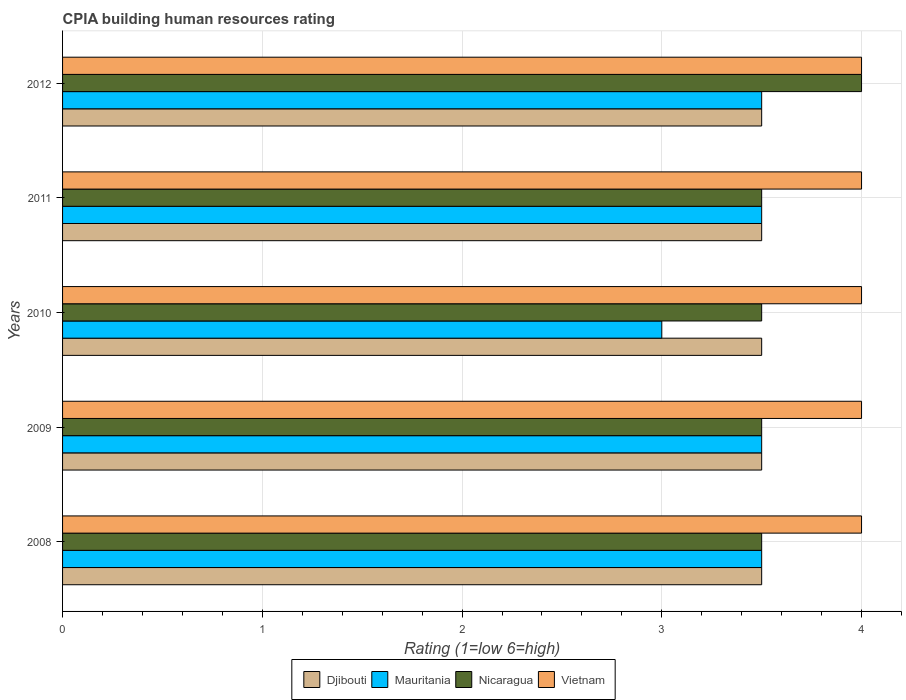How many different coloured bars are there?
Provide a short and direct response. 4. Are the number of bars per tick equal to the number of legend labels?
Ensure brevity in your answer.  Yes. How many bars are there on the 4th tick from the bottom?
Offer a very short reply. 4. Across all years, what is the maximum CPIA rating in Vietnam?
Provide a succinct answer. 4. Across all years, what is the minimum CPIA rating in Djibouti?
Offer a terse response. 3.5. In which year was the CPIA rating in Vietnam maximum?
Make the answer very short. 2008. What is the total CPIA rating in Mauritania in the graph?
Your response must be concise. 17. What is the difference between the CPIA rating in Djibouti in 2011 and the CPIA rating in Mauritania in 2008?
Offer a very short reply. 0. In how many years, is the CPIA rating in Vietnam greater than 2.6 ?
Keep it short and to the point. 5. Is the CPIA rating in Vietnam in 2008 less than that in 2011?
Your answer should be compact. No. Is the difference between the CPIA rating in Mauritania in 2009 and 2010 greater than the difference between the CPIA rating in Djibouti in 2009 and 2010?
Give a very brief answer. Yes. Is it the case that in every year, the sum of the CPIA rating in Nicaragua and CPIA rating in Vietnam is greater than the sum of CPIA rating in Mauritania and CPIA rating in Djibouti?
Provide a short and direct response. Yes. What does the 2nd bar from the top in 2009 represents?
Provide a succinct answer. Nicaragua. What does the 3rd bar from the bottom in 2012 represents?
Provide a short and direct response. Nicaragua. Is it the case that in every year, the sum of the CPIA rating in Nicaragua and CPIA rating in Djibouti is greater than the CPIA rating in Mauritania?
Provide a short and direct response. Yes. How many years are there in the graph?
Provide a short and direct response. 5. What is the difference between two consecutive major ticks on the X-axis?
Your answer should be very brief. 1. Where does the legend appear in the graph?
Ensure brevity in your answer.  Bottom center. What is the title of the graph?
Provide a succinct answer. CPIA building human resources rating. What is the label or title of the Y-axis?
Your response must be concise. Years. What is the Rating (1=low 6=high) in Djibouti in 2008?
Your answer should be very brief. 3.5. What is the Rating (1=low 6=high) of Vietnam in 2008?
Provide a succinct answer. 4. What is the Rating (1=low 6=high) of Djibouti in 2009?
Give a very brief answer. 3.5. What is the Rating (1=low 6=high) of Mauritania in 2009?
Provide a succinct answer. 3.5. What is the Rating (1=low 6=high) of Djibouti in 2011?
Ensure brevity in your answer.  3.5. What is the Rating (1=low 6=high) in Djibouti in 2012?
Offer a very short reply. 3.5. What is the Rating (1=low 6=high) of Mauritania in 2012?
Your response must be concise. 3.5. What is the Rating (1=low 6=high) in Nicaragua in 2012?
Ensure brevity in your answer.  4. What is the Rating (1=low 6=high) of Vietnam in 2012?
Provide a succinct answer. 4. Across all years, what is the maximum Rating (1=low 6=high) in Djibouti?
Provide a succinct answer. 3.5. Across all years, what is the maximum Rating (1=low 6=high) in Nicaragua?
Your response must be concise. 4. Across all years, what is the maximum Rating (1=low 6=high) of Vietnam?
Your response must be concise. 4. Across all years, what is the minimum Rating (1=low 6=high) of Vietnam?
Your answer should be compact. 4. What is the total Rating (1=low 6=high) of Nicaragua in the graph?
Offer a terse response. 18. What is the difference between the Rating (1=low 6=high) of Vietnam in 2008 and that in 2009?
Ensure brevity in your answer.  0. What is the difference between the Rating (1=low 6=high) in Djibouti in 2008 and that in 2010?
Offer a very short reply. 0. What is the difference between the Rating (1=low 6=high) in Mauritania in 2008 and that in 2010?
Give a very brief answer. 0.5. What is the difference between the Rating (1=low 6=high) of Nicaragua in 2008 and that in 2010?
Keep it short and to the point. 0. What is the difference between the Rating (1=low 6=high) in Djibouti in 2008 and that in 2011?
Offer a terse response. 0. What is the difference between the Rating (1=low 6=high) of Vietnam in 2008 and that in 2011?
Your response must be concise. 0. What is the difference between the Rating (1=low 6=high) of Mauritania in 2008 and that in 2012?
Keep it short and to the point. 0. What is the difference between the Rating (1=low 6=high) in Vietnam in 2008 and that in 2012?
Offer a very short reply. 0. What is the difference between the Rating (1=low 6=high) of Djibouti in 2009 and that in 2010?
Your answer should be very brief. 0. What is the difference between the Rating (1=low 6=high) of Nicaragua in 2009 and that in 2010?
Provide a succinct answer. 0. What is the difference between the Rating (1=low 6=high) in Vietnam in 2009 and that in 2010?
Keep it short and to the point. 0. What is the difference between the Rating (1=low 6=high) in Nicaragua in 2009 and that in 2011?
Your answer should be compact. 0. What is the difference between the Rating (1=low 6=high) in Djibouti in 2010 and that in 2011?
Ensure brevity in your answer.  0. What is the difference between the Rating (1=low 6=high) in Vietnam in 2010 and that in 2011?
Give a very brief answer. 0. What is the difference between the Rating (1=low 6=high) of Djibouti in 2010 and that in 2012?
Provide a succinct answer. 0. What is the difference between the Rating (1=low 6=high) in Nicaragua in 2010 and that in 2012?
Offer a terse response. -0.5. What is the difference between the Rating (1=low 6=high) in Djibouti in 2011 and that in 2012?
Ensure brevity in your answer.  0. What is the difference between the Rating (1=low 6=high) of Mauritania in 2011 and that in 2012?
Your response must be concise. 0. What is the difference between the Rating (1=low 6=high) of Djibouti in 2008 and the Rating (1=low 6=high) of Mauritania in 2009?
Keep it short and to the point. 0. What is the difference between the Rating (1=low 6=high) of Mauritania in 2008 and the Rating (1=low 6=high) of Nicaragua in 2009?
Your response must be concise. 0. What is the difference between the Rating (1=low 6=high) in Nicaragua in 2008 and the Rating (1=low 6=high) in Vietnam in 2009?
Ensure brevity in your answer.  -0.5. What is the difference between the Rating (1=low 6=high) of Djibouti in 2008 and the Rating (1=low 6=high) of Nicaragua in 2010?
Offer a terse response. 0. What is the difference between the Rating (1=low 6=high) of Djibouti in 2008 and the Rating (1=low 6=high) of Vietnam in 2010?
Ensure brevity in your answer.  -0.5. What is the difference between the Rating (1=low 6=high) in Djibouti in 2008 and the Rating (1=low 6=high) in Vietnam in 2011?
Your response must be concise. -0.5. What is the difference between the Rating (1=low 6=high) of Mauritania in 2008 and the Rating (1=low 6=high) of Nicaragua in 2011?
Ensure brevity in your answer.  0. What is the difference between the Rating (1=low 6=high) of Mauritania in 2008 and the Rating (1=low 6=high) of Vietnam in 2011?
Your answer should be compact. -0.5. What is the difference between the Rating (1=low 6=high) of Nicaragua in 2008 and the Rating (1=low 6=high) of Vietnam in 2011?
Provide a succinct answer. -0.5. What is the difference between the Rating (1=low 6=high) in Djibouti in 2008 and the Rating (1=low 6=high) in Mauritania in 2012?
Offer a very short reply. 0. What is the difference between the Rating (1=low 6=high) of Djibouti in 2008 and the Rating (1=low 6=high) of Nicaragua in 2012?
Your answer should be compact. -0.5. What is the difference between the Rating (1=low 6=high) in Djibouti in 2008 and the Rating (1=low 6=high) in Vietnam in 2012?
Provide a succinct answer. -0.5. What is the difference between the Rating (1=low 6=high) of Mauritania in 2008 and the Rating (1=low 6=high) of Nicaragua in 2012?
Keep it short and to the point. -0.5. What is the difference between the Rating (1=low 6=high) in Nicaragua in 2008 and the Rating (1=low 6=high) in Vietnam in 2012?
Your response must be concise. -0.5. What is the difference between the Rating (1=low 6=high) in Djibouti in 2009 and the Rating (1=low 6=high) in Mauritania in 2010?
Provide a short and direct response. 0.5. What is the difference between the Rating (1=low 6=high) of Djibouti in 2009 and the Rating (1=low 6=high) of Nicaragua in 2010?
Your response must be concise. 0. What is the difference between the Rating (1=low 6=high) in Djibouti in 2009 and the Rating (1=low 6=high) in Vietnam in 2010?
Provide a short and direct response. -0.5. What is the difference between the Rating (1=low 6=high) of Mauritania in 2009 and the Rating (1=low 6=high) of Nicaragua in 2010?
Offer a very short reply. 0. What is the difference between the Rating (1=low 6=high) of Nicaragua in 2009 and the Rating (1=low 6=high) of Vietnam in 2010?
Give a very brief answer. -0.5. What is the difference between the Rating (1=low 6=high) in Djibouti in 2009 and the Rating (1=low 6=high) in Mauritania in 2011?
Your answer should be compact. 0. What is the difference between the Rating (1=low 6=high) of Djibouti in 2009 and the Rating (1=low 6=high) of Vietnam in 2011?
Your answer should be very brief. -0.5. What is the difference between the Rating (1=low 6=high) in Djibouti in 2009 and the Rating (1=low 6=high) in Vietnam in 2012?
Keep it short and to the point. -0.5. What is the difference between the Rating (1=low 6=high) of Nicaragua in 2009 and the Rating (1=low 6=high) of Vietnam in 2012?
Your answer should be very brief. -0.5. What is the difference between the Rating (1=low 6=high) in Djibouti in 2010 and the Rating (1=low 6=high) in Mauritania in 2011?
Provide a succinct answer. 0. What is the difference between the Rating (1=low 6=high) of Djibouti in 2010 and the Rating (1=low 6=high) of Vietnam in 2011?
Ensure brevity in your answer.  -0.5. What is the difference between the Rating (1=low 6=high) in Mauritania in 2010 and the Rating (1=low 6=high) in Nicaragua in 2011?
Provide a succinct answer. -0.5. What is the difference between the Rating (1=low 6=high) of Mauritania in 2010 and the Rating (1=low 6=high) of Vietnam in 2011?
Keep it short and to the point. -1. What is the difference between the Rating (1=low 6=high) of Mauritania in 2010 and the Rating (1=low 6=high) of Nicaragua in 2012?
Make the answer very short. -1. What is the difference between the Rating (1=low 6=high) of Mauritania in 2010 and the Rating (1=low 6=high) of Vietnam in 2012?
Offer a very short reply. -1. What is the difference between the Rating (1=low 6=high) in Djibouti in 2011 and the Rating (1=low 6=high) in Vietnam in 2012?
Provide a succinct answer. -0.5. What is the average Rating (1=low 6=high) in Nicaragua per year?
Offer a terse response. 3.6. What is the average Rating (1=low 6=high) of Vietnam per year?
Your answer should be very brief. 4. In the year 2008, what is the difference between the Rating (1=low 6=high) in Djibouti and Rating (1=low 6=high) in Vietnam?
Offer a very short reply. -0.5. In the year 2009, what is the difference between the Rating (1=low 6=high) in Djibouti and Rating (1=low 6=high) in Vietnam?
Make the answer very short. -0.5. In the year 2009, what is the difference between the Rating (1=low 6=high) in Mauritania and Rating (1=low 6=high) in Vietnam?
Offer a terse response. -0.5. In the year 2010, what is the difference between the Rating (1=low 6=high) of Djibouti and Rating (1=low 6=high) of Nicaragua?
Make the answer very short. 0. In the year 2010, what is the difference between the Rating (1=low 6=high) of Djibouti and Rating (1=low 6=high) of Vietnam?
Your answer should be very brief. -0.5. In the year 2010, what is the difference between the Rating (1=low 6=high) in Mauritania and Rating (1=low 6=high) in Nicaragua?
Your answer should be compact. -0.5. In the year 2010, what is the difference between the Rating (1=low 6=high) of Mauritania and Rating (1=low 6=high) of Vietnam?
Make the answer very short. -1. In the year 2011, what is the difference between the Rating (1=low 6=high) in Djibouti and Rating (1=low 6=high) in Mauritania?
Give a very brief answer. 0. In the year 2011, what is the difference between the Rating (1=low 6=high) of Djibouti and Rating (1=low 6=high) of Nicaragua?
Your answer should be very brief. 0. In the year 2011, what is the difference between the Rating (1=low 6=high) in Djibouti and Rating (1=low 6=high) in Vietnam?
Offer a very short reply. -0.5. In the year 2011, what is the difference between the Rating (1=low 6=high) of Mauritania and Rating (1=low 6=high) of Nicaragua?
Provide a short and direct response. 0. In the year 2011, what is the difference between the Rating (1=low 6=high) of Mauritania and Rating (1=low 6=high) of Vietnam?
Offer a terse response. -0.5. In the year 2011, what is the difference between the Rating (1=low 6=high) in Nicaragua and Rating (1=low 6=high) in Vietnam?
Keep it short and to the point. -0.5. In the year 2012, what is the difference between the Rating (1=low 6=high) of Djibouti and Rating (1=low 6=high) of Mauritania?
Your response must be concise. 0. In the year 2012, what is the difference between the Rating (1=low 6=high) in Djibouti and Rating (1=low 6=high) in Vietnam?
Provide a succinct answer. -0.5. In the year 2012, what is the difference between the Rating (1=low 6=high) in Mauritania and Rating (1=low 6=high) in Nicaragua?
Give a very brief answer. -0.5. In the year 2012, what is the difference between the Rating (1=low 6=high) in Mauritania and Rating (1=low 6=high) in Vietnam?
Your response must be concise. -0.5. In the year 2012, what is the difference between the Rating (1=low 6=high) in Nicaragua and Rating (1=low 6=high) in Vietnam?
Your response must be concise. 0. What is the ratio of the Rating (1=low 6=high) in Vietnam in 2008 to that in 2009?
Give a very brief answer. 1. What is the ratio of the Rating (1=low 6=high) in Djibouti in 2008 to that in 2010?
Give a very brief answer. 1. What is the ratio of the Rating (1=low 6=high) in Mauritania in 2008 to that in 2010?
Provide a succinct answer. 1.17. What is the ratio of the Rating (1=low 6=high) in Nicaragua in 2008 to that in 2010?
Keep it short and to the point. 1. What is the ratio of the Rating (1=low 6=high) in Vietnam in 2008 to that in 2010?
Offer a terse response. 1. What is the ratio of the Rating (1=low 6=high) in Vietnam in 2008 to that in 2011?
Ensure brevity in your answer.  1. What is the ratio of the Rating (1=low 6=high) of Djibouti in 2008 to that in 2012?
Keep it short and to the point. 1. What is the ratio of the Rating (1=low 6=high) of Mauritania in 2008 to that in 2012?
Offer a very short reply. 1. What is the ratio of the Rating (1=low 6=high) in Nicaragua in 2008 to that in 2012?
Offer a very short reply. 0.88. What is the ratio of the Rating (1=low 6=high) of Djibouti in 2009 to that in 2010?
Your answer should be very brief. 1. What is the ratio of the Rating (1=low 6=high) in Vietnam in 2009 to that in 2010?
Keep it short and to the point. 1. What is the ratio of the Rating (1=low 6=high) of Djibouti in 2009 to that in 2011?
Offer a terse response. 1. What is the ratio of the Rating (1=low 6=high) in Mauritania in 2009 to that in 2011?
Provide a short and direct response. 1. What is the ratio of the Rating (1=low 6=high) in Mauritania in 2009 to that in 2012?
Your answer should be compact. 1. What is the ratio of the Rating (1=low 6=high) in Djibouti in 2010 to that in 2011?
Make the answer very short. 1. What is the ratio of the Rating (1=low 6=high) in Mauritania in 2010 to that in 2011?
Ensure brevity in your answer.  0.86. What is the ratio of the Rating (1=low 6=high) of Mauritania in 2010 to that in 2012?
Provide a short and direct response. 0.86. What is the ratio of the Rating (1=low 6=high) in Nicaragua in 2010 to that in 2012?
Your response must be concise. 0.88. What is the ratio of the Rating (1=low 6=high) of Djibouti in 2011 to that in 2012?
Keep it short and to the point. 1. What is the ratio of the Rating (1=low 6=high) in Mauritania in 2011 to that in 2012?
Make the answer very short. 1. What is the ratio of the Rating (1=low 6=high) in Vietnam in 2011 to that in 2012?
Keep it short and to the point. 1. What is the difference between the highest and the second highest Rating (1=low 6=high) of Vietnam?
Keep it short and to the point. 0. What is the difference between the highest and the lowest Rating (1=low 6=high) of Nicaragua?
Your response must be concise. 0.5. 